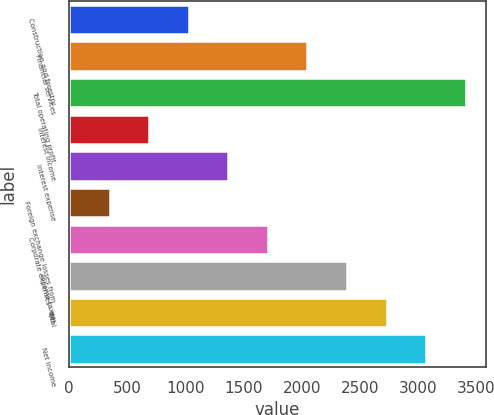Convert chart. <chart><loc_0><loc_0><loc_500><loc_500><bar_chart><fcel>Construction and forestry<fcel>Financial services<fcel>Total operating profit<fcel>Interest income<fcel>Interest expense<fcel>Foreign exchange losses from<fcel>Corporate expenses - net<fcel>Income taxes<fcel>Total<fcel>Net income<nl><fcel>1028.7<fcel>2048.4<fcel>3408<fcel>688.8<fcel>1368.6<fcel>348.9<fcel>1708.5<fcel>2388.3<fcel>2728.2<fcel>3068.1<nl></chart> 